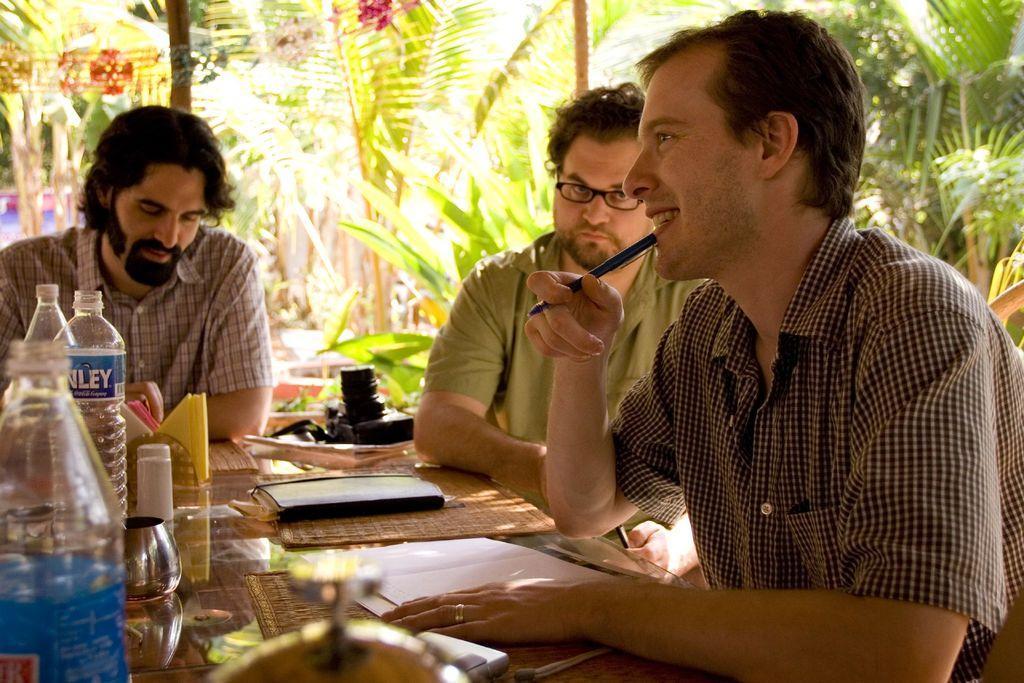Could you give a brief overview of what you see in this image? In this picture we can see three persons sitting on the chairs. He hold a pen with his hand. He has spectacles. This is the table, on the table there are bottles, paper, book, and a camera. On the background we can see some trees. 